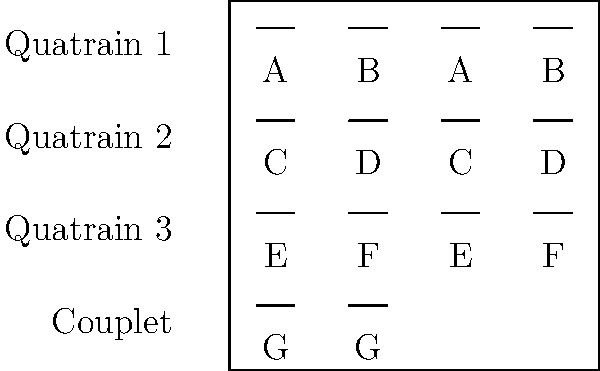Analyze the structure of the Shakespearean sonnet represented in the diagram. How does this rhyme scheme contribute to the overall development of ideas within the sonnet, and what literary effect does the final couplet typically serve? 1. Identify the structure: The diagram shows the rhyme scheme of a Shakespearean sonnet, which consists of three quatrains and a concluding couplet.

2. Analyze the rhyme scheme:
   - Quatrain 1: ABAB
   - Quatrain 2: CDCD
   - Quatrain 3: EFEF
   - Couplet: GG

3. Understand the development of ideas:
   - Each quatrain typically introduces and develops a new idea or perspective on the sonnet's theme.
   - The alternating rhyme scheme (ABAB, CDCD, EFEF) creates a rhythmic flow that helps to structure these ideas.
   - The shift in rhyme between quatrains (from ABAB to CDCD to EFEF) often signals a shift in thought or perspective.

4. Examine the role of the couplet:
   - The final couplet (GG) stands out with its paired rhyme.
   - It typically serves to conclude the sonnet by:
     a) Summarizing the main ideas
     b) Offering a resolution to a problem or question posed in the quatrains
     c) Providing a surprising twist or new perspective on the theme

5. Consider the literary effect:
   - The structure allows for a logical progression of ideas through the quatrains.
   - The couplet's different rhyme scheme creates emphasis, making it memorable and impactful.
   - This structure supports the sonnet's traditional function of exploring complex emotions or ideas in a condensed form.
Answer: The Shakespearean sonnet's rhyme scheme (ABAB CDCD EFEF GG) facilitates a structured development of ideas across three quatrains, with the final couplet providing a powerful conclusion or twist. 